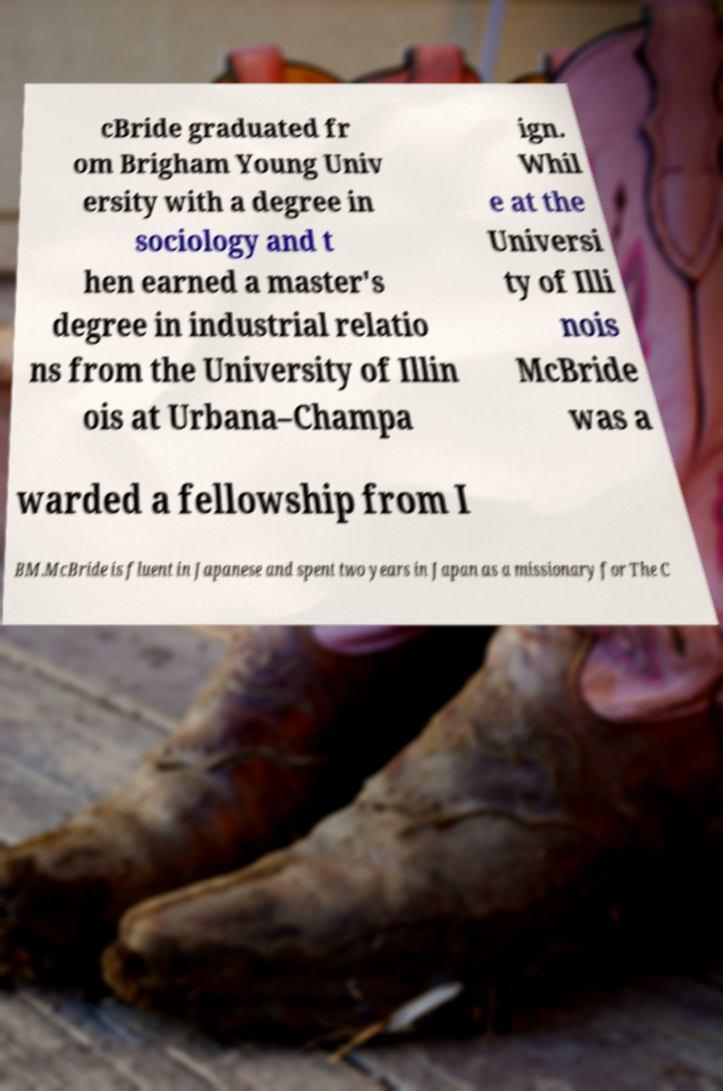What messages or text are displayed in this image? I need them in a readable, typed format. cBride graduated fr om Brigham Young Univ ersity with a degree in sociology and t hen earned a master's degree in industrial relatio ns from the University of Illin ois at Urbana–Champa ign. Whil e at the Universi ty of Illi nois McBride was a warded a fellowship from I BM.McBride is fluent in Japanese and spent two years in Japan as a missionary for The C 